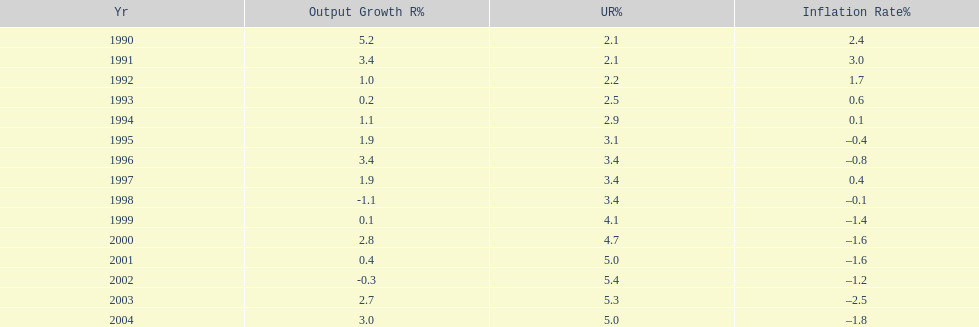What year saw the highest output growth rate in japan between the years 1990 and 2004? 1990. 